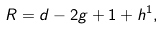Convert formula to latex. <formula><loc_0><loc_0><loc_500><loc_500>R = d - 2 g + 1 + h ^ { 1 } ,</formula> 